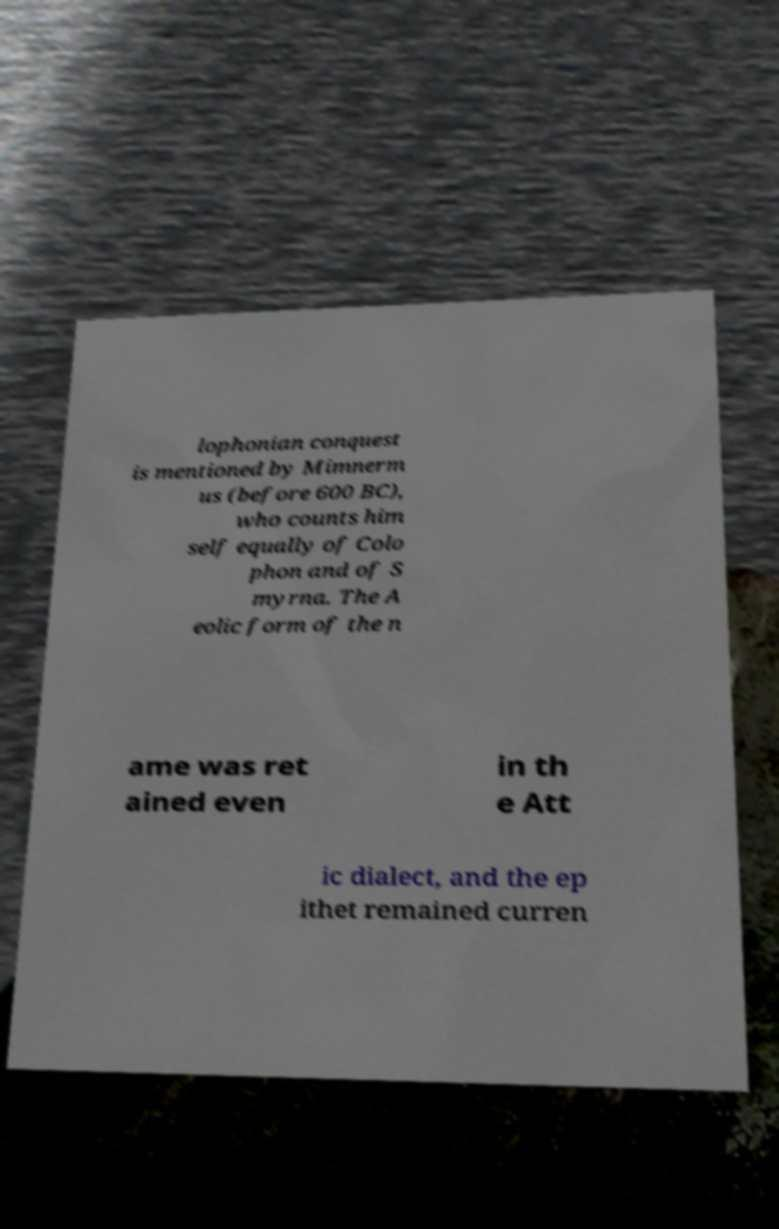Could you assist in decoding the text presented in this image and type it out clearly? lophonian conquest is mentioned by Mimnerm us (before 600 BC), who counts him self equally of Colo phon and of S myrna. The A eolic form of the n ame was ret ained even in th e Att ic dialect, and the ep ithet remained curren 